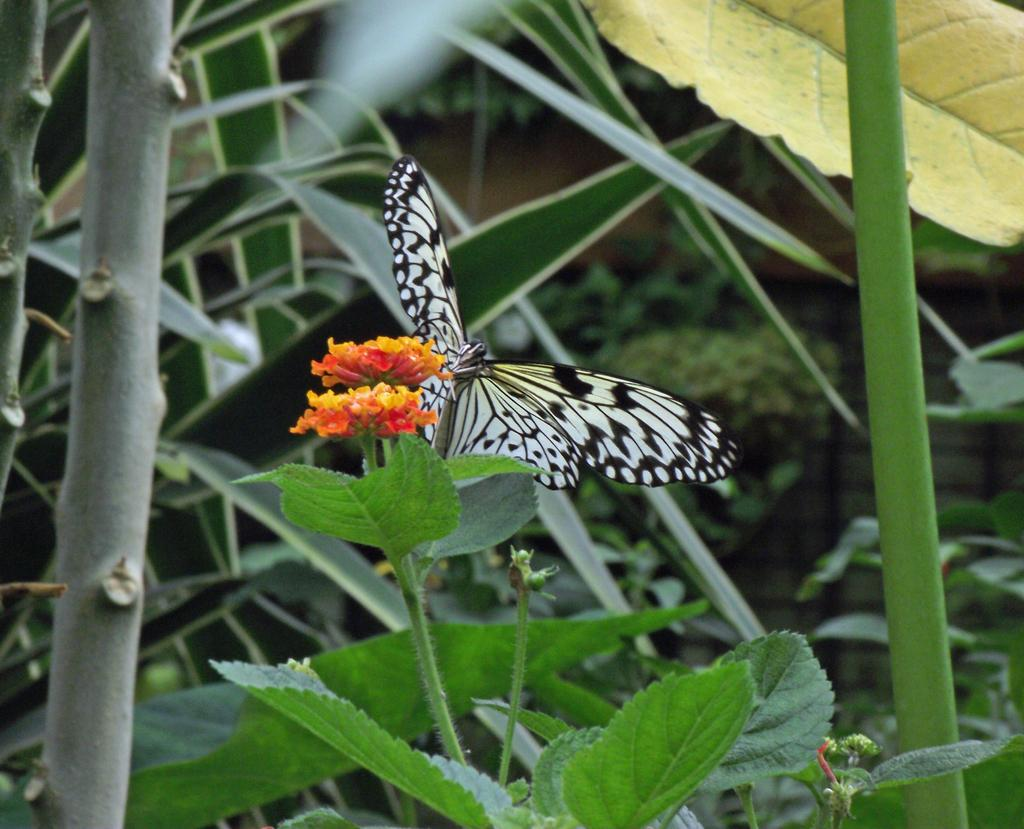What is the main subject of the image? There is a butterfly in the image. What is the butterfly doing in the image? The butterfly is standing on a flower. What can be seen in the background of the image? There are planets and a building visible in the background of the image. What type of vegetation is present at the bottom of the image? Leaves are present at the bottom of the image. Can you see any pigs at the zoo in the image? There is no zoo or pig present in the image. What type of farm animals can be seen in the image? There are no farm animals present in the image; it features a butterfly standing on a flower with planets and a building in the background. 